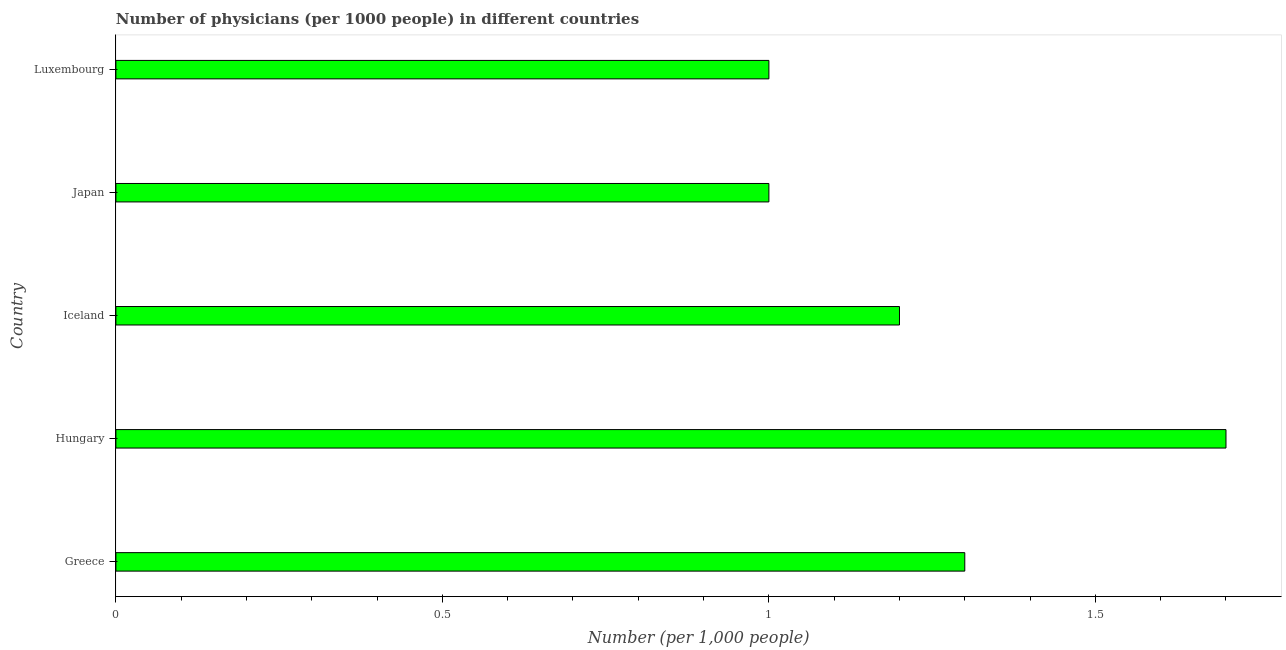Does the graph contain any zero values?
Your response must be concise. No. Does the graph contain grids?
Keep it short and to the point. No. What is the title of the graph?
Keep it short and to the point. Number of physicians (per 1000 people) in different countries. What is the label or title of the X-axis?
Your answer should be compact. Number (per 1,0 people). What is the number of physicians in Greece?
Your answer should be compact. 1.3. Across all countries, what is the maximum number of physicians?
Offer a terse response. 1.7. Across all countries, what is the minimum number of physicians?
Provide a short and direct response. 1. In which country was the number of physicians maximum?
Your answer should be compact. Hungary. What is the average number of physicians per country?
Keep it short and to the point. 1.24. What is the median number of physicians?
Provide a short and direct response. 1.2. Is the number of physicians in Greece less than that in Luxembourg?
Give a very brief answer. No. Is the difference between the number of physicians in Iceland and Luxembourg greater than the difference between any two countries?
Keep it short and to the point. No. What is the difference between the highest and the second highest number of physicians?
Your answer should be very brief. 0.4. How many bars are there?
Ensure brevity in your answer.  5. Are all the bars in the graph horizontal?
Ensure brevity in your answer.  Yes. What is the Number (per 1,000 people) of Iceland?
Your response must be concise. 1.2. What is the Number (per 1,000 people) of Japan?
Provide a short and direct response. 1. What is the difference between the Number (per 1,000 people) in Greece and Hungary?
Ensure brevity in your answer.  -0.4. What is the difference between the Number (per 1,000 people) in Hungary and Japan?
Provide a succinct answer. 0.7. What is the difference between the Number (per 1,000 people) in Iceland and Japan?
Your response must be concise. 0.2. What is the ratio of the Number (per 1,000 people) in Greece to that in Hungary?
Your answer should be compact. 0.77. What is the ratio of the Number (per 1,000 people) in Greece to that in Iceland?
Offer a terse response. 1.08. What is the ratio of the Number (per 1,000 people) in Hungary to that in Iceland?
Provide a short and direct response. 1.42. What is the ratio of the Number (per 1,000 people) in Hungary to that in Japan?
Make the answer very short. 1.7. What is the ratio of the Number (per 1,000 people) in Iceland to that in Japan?
Your answer should be very brief. 1.2. What is the ratio of the Number (per 1,000 people) in Japan to that in Luxembourg?
Keep it short and to the point. 1. 